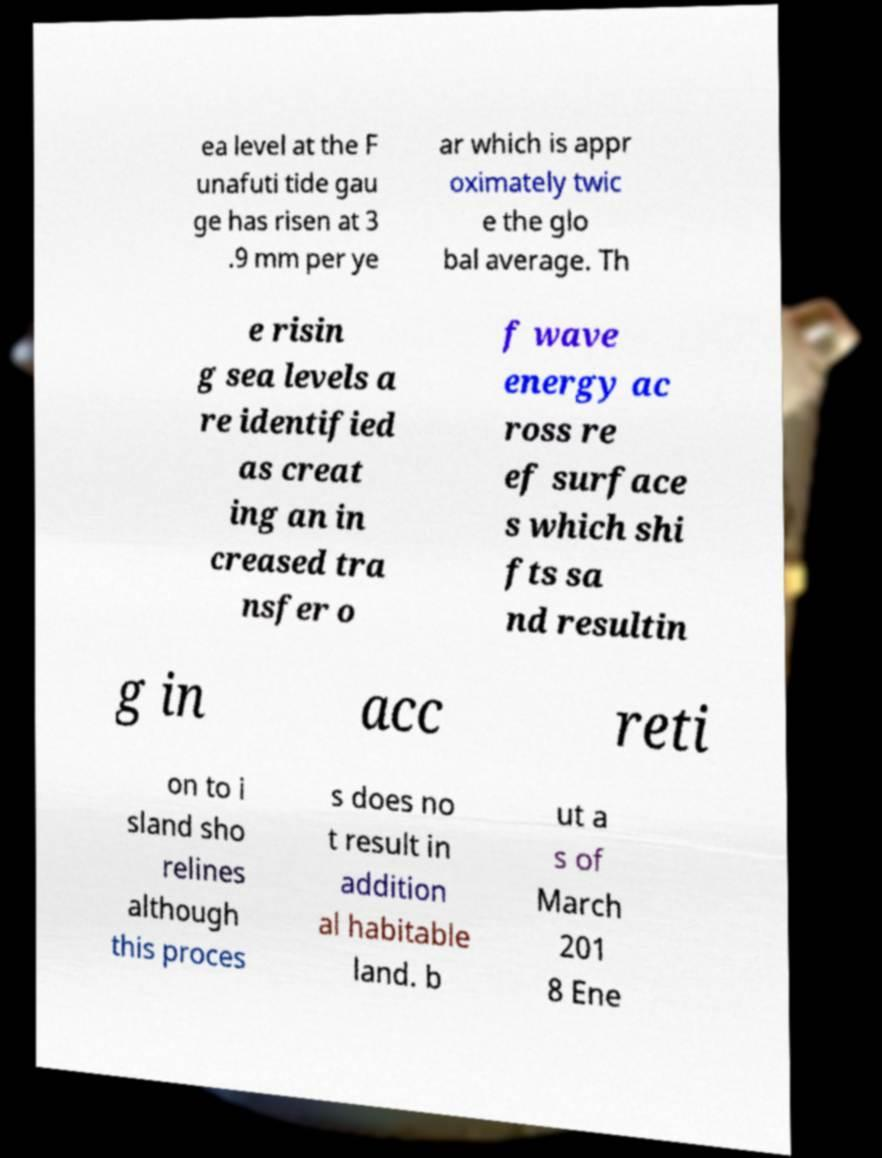There's text embedded in this image that I need extracted. Can you transcribe it verbatim? ea level at the F unafuti tide gau ge has risen at 3 .9 mm per ye ar which is appr oximately twic e the glo bal average. Th e risin g sea levels a re identified as creat ing an in creased tra nsfer o f wave energy ac ross re ef surface s which shi fts sa nd resultin g in acc reti on to i sland sho relines although this proces s does no t result in addition al habitable land. b ut a s of March 201 8 Ene 